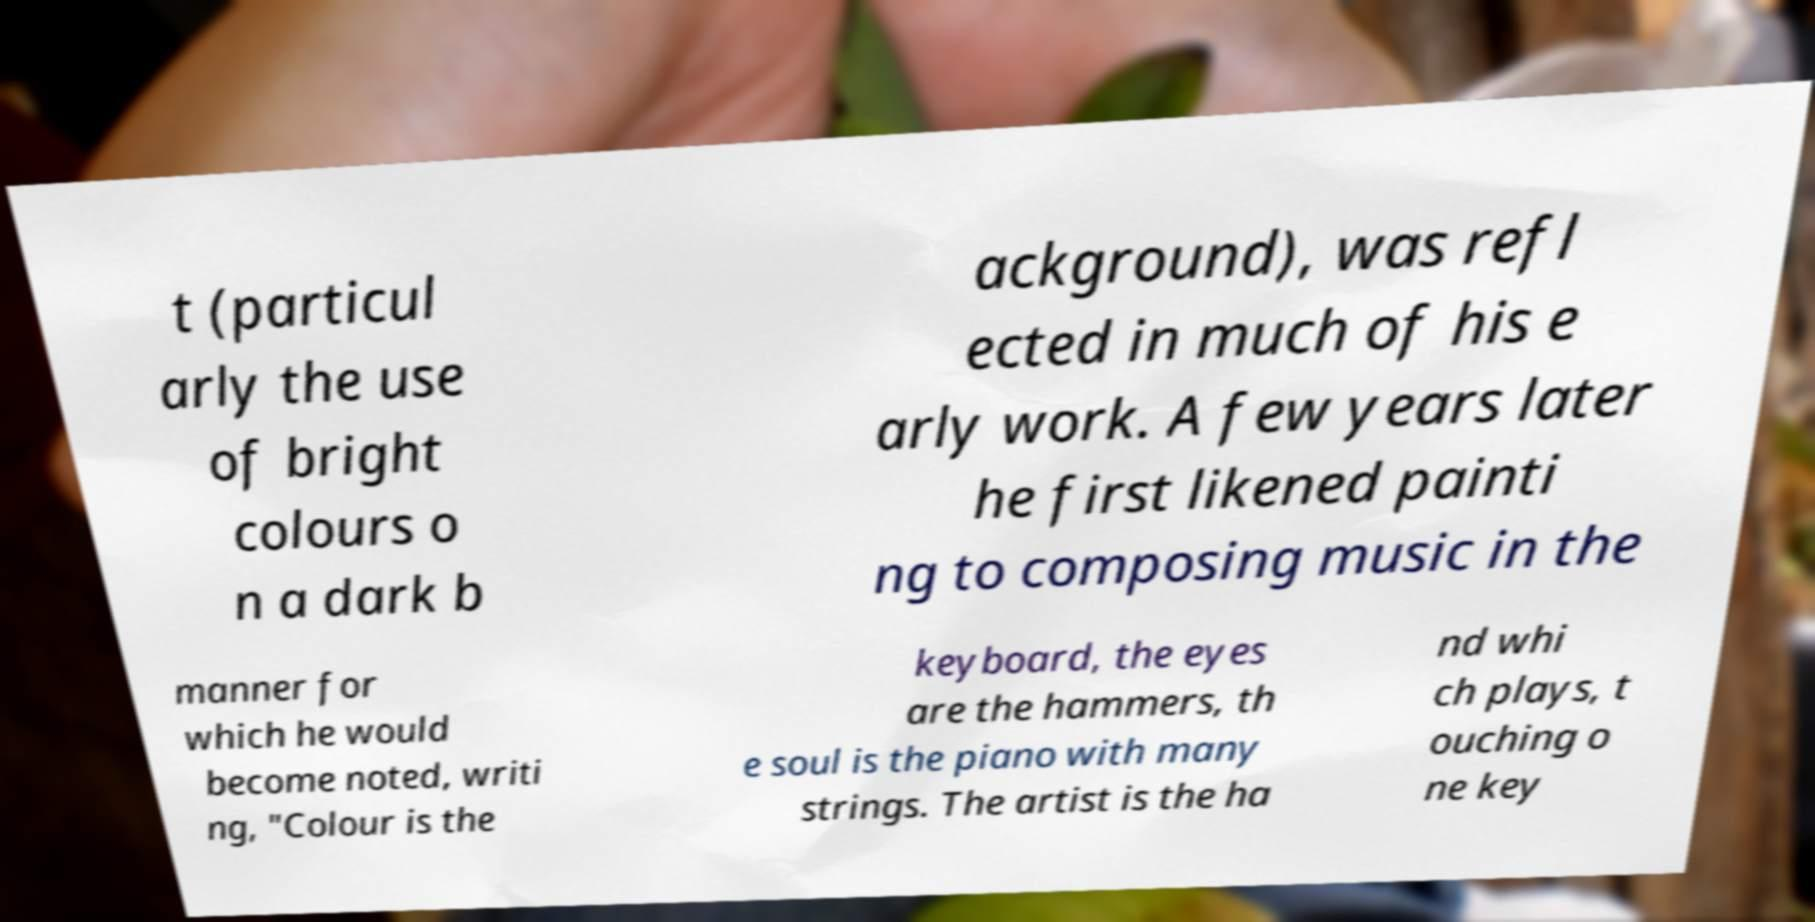I need the written content from this picture converted into text. Can you do that? t (particul arly the use of bright colours o n a dark b ackground), was refl ected in much of his e arly work. A few years later he first likened painti ng to composing music in the manner for which he would become noted, writi ng, "Colour is the keyboard, the eyes are the hammers, th e soul is the piano with many strings. The artist is the ha nd whi ch plays, t ouching o ne key 